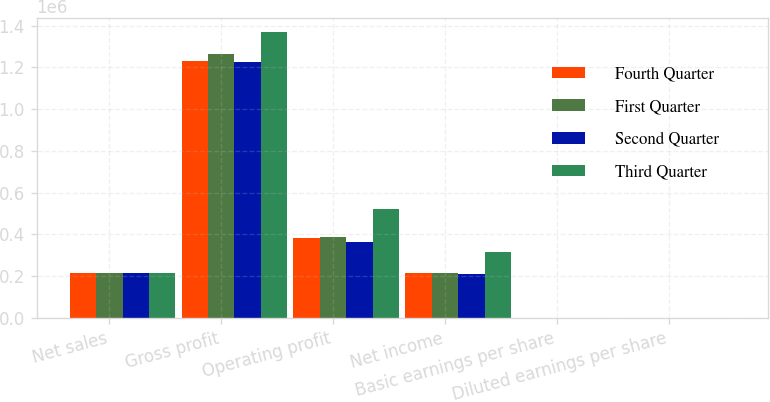Convert chart to OTSL. <chart><loc_0><loc_0><loc_500><loc_500><stacked_bar_chart><ecel><fcel>Net sales<fcel>Gross profit<fcel>Operating profit<fcel>Net income<fcel>Basic earnings per share<fcel>Diluted earnings per share<nl><fcel>Fourth Quarter<fcel>213778<fcel>1.22826e+06<fcel>384324<fcel>213415<fcel>0.64<fcel>0.63<nl><fcel>First Quarter<fcel>213778<fcel>1.26322e+06<fcel>387214<fcel>214140<fcel>0.64<fcel>0.64<nl><fcel>Second Quarter<fcel>213778<fcel>1.22612e+06<fcel>361389<fcel>207685<fcel>0.62<fcel>0.62<nl><fcel>Third Quarter<fcel>213778<fcel>1.3678e+06<fcel>522349<fcel>317422<fcel>0.97<fcel>0.97<nl></chart> 